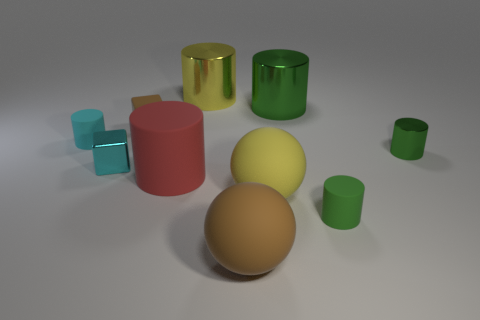How many green cylinders must be subtracted to get 1 green cylinders? 2 Subtract all blue spheres. How many green cylinders are left? 3 Subtract all cyan matte cylinders. How many cylinders are left? 5 Subtract 3 cylinders. How many cylinders are left? 3 Subtract all cyan cylinders. How many cylinders are left? 5 Subtract all blue cylinders. Subtract all brown balls. How many cylinders are left? 6 Subtract all cubes. How many objects are left? 8 Add 7 large green cylinders. How many large green cylinders exist? 8 Subtract 1 brown blocks. How many objects are left? 9 Subtract all large rubber blocks. Subtract all rubber spheres. How many objects are left? 8 